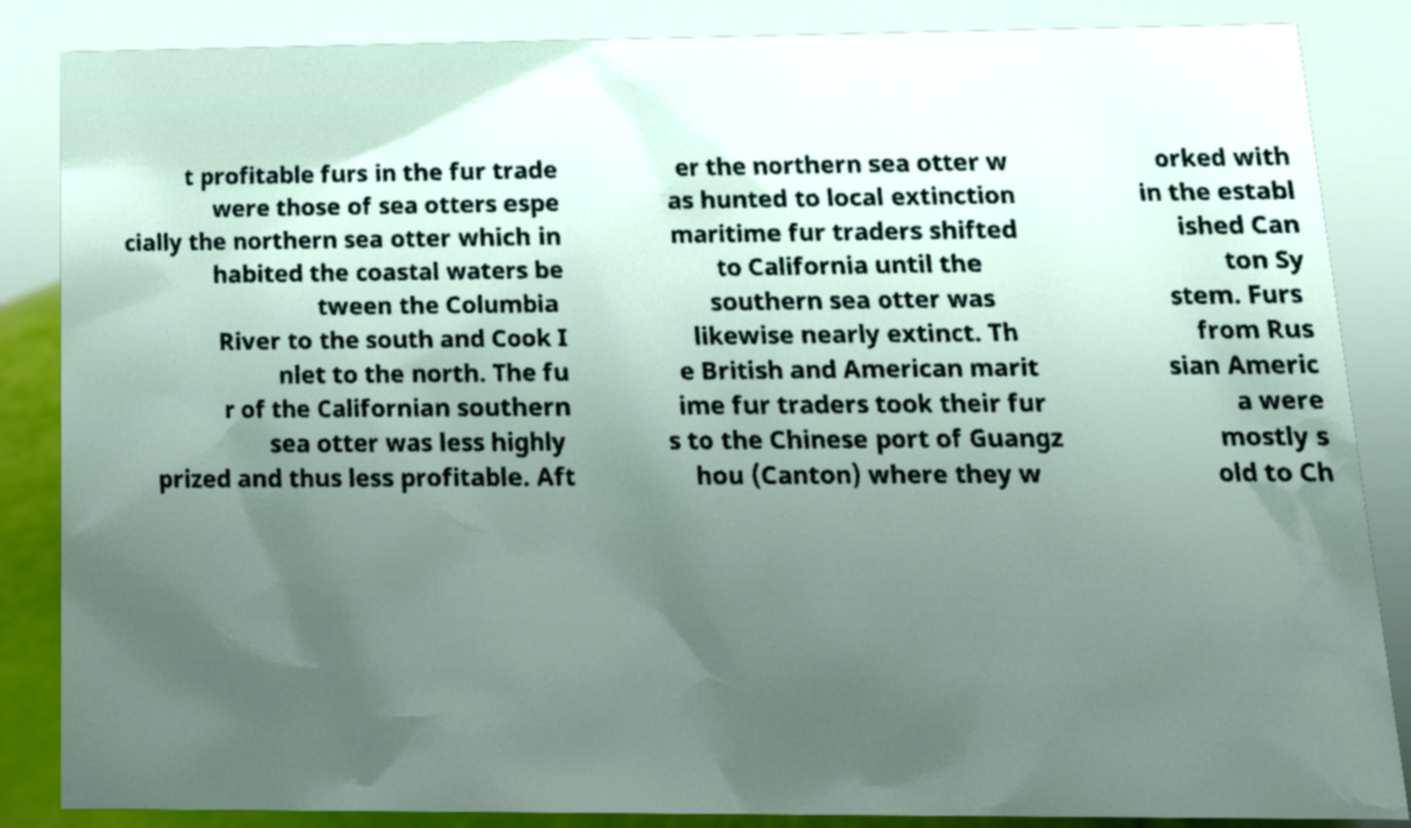I need the written content from this picture converted into text. Can you do that? t profitable furs in the fur trade were those of sea otters espe cially the northern sea otter which in habited the coastal waters be tween the Columbia River to the south and Cook I nlet to the north. The fu r of the Californian southern sea otter was less highly prized and thus less profitable. Aft er the northern sea otter w as hunted to local extinction maritime fur traders shifted to California until the southern sea otter was likewise nearly extinct. Th e British and American marit ime fur traders took their fur s to the Chinese port of Guangz hou (Canton) where they w orked with in the establ ished Can ton Sy stem. Furs from Rus sian Americ a were mostly s old to Ch 